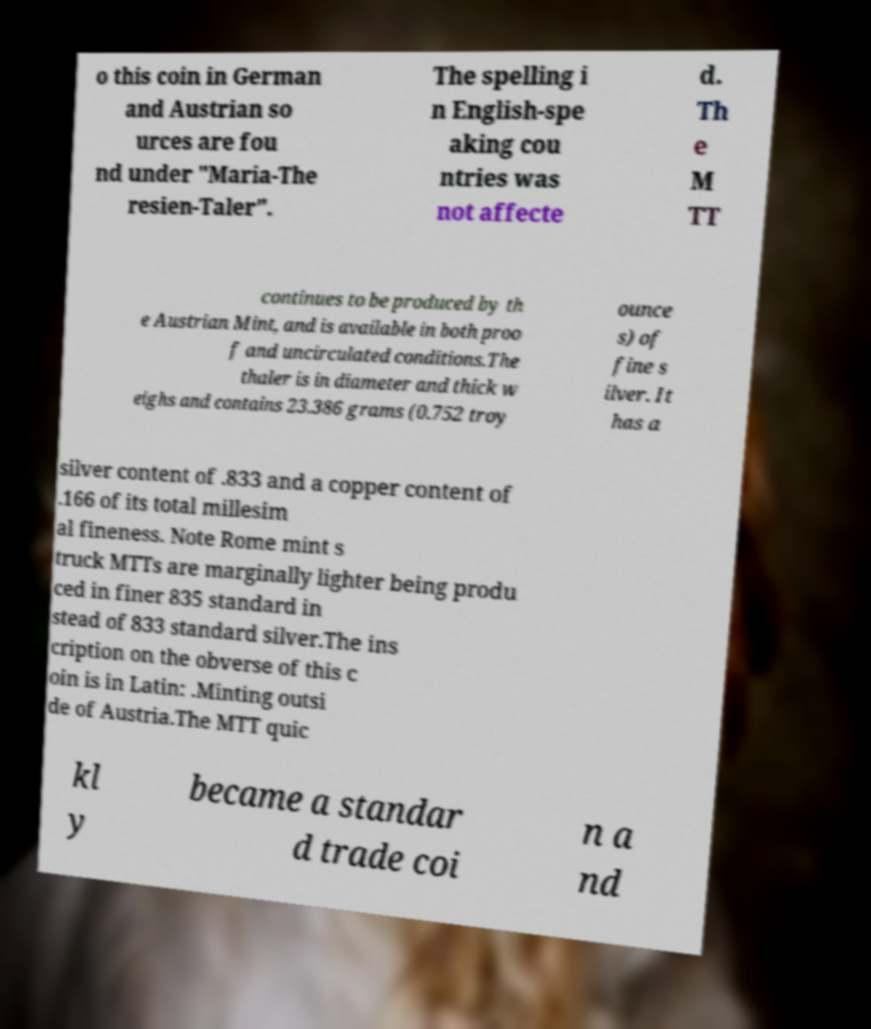Please identify and transcribe the text found in this image. o this coin in German and Austrian so urces are fou nd under "Maria-The resien-Taler". The spelling i n English-spe aking cou ntries was not affecte d. Th e M TT continues to be produced by th e Austrian Mint, and is available in both proo f and uncirculated conditions.The thaler is in diameter and thick w eighs and contains 23.386 grams (0.752 troy ounce s) of fine s ilver. It has a silver content of .833 and a copper content of .166 of its total millesim al fineness. Note Rome mint s truck MTTs are marginally lighter being produ ced in finer 835 standard in stead of 833 standard silver.The ins cription on the obverse of this c oin is in Latin: .Minting outsi de of Austria.The MTT quic kl y became a standar d trade coi n a nd 